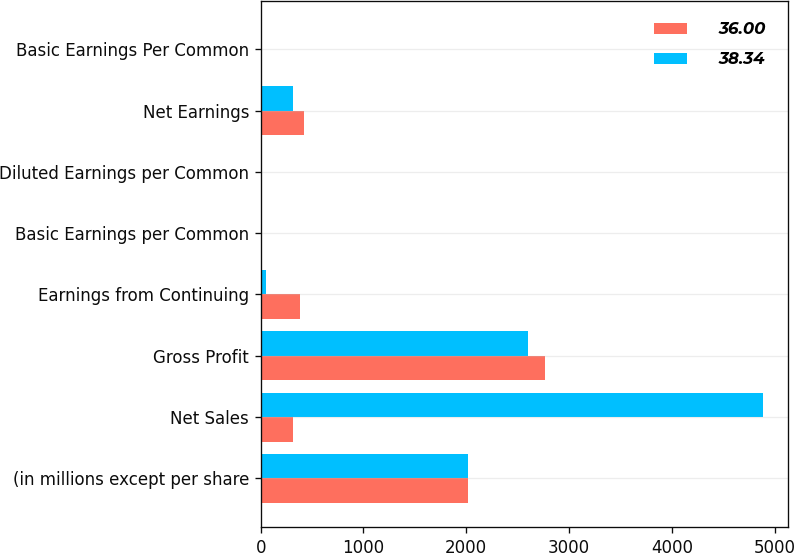<chart> <loc_0><loc_0><loc_500><loc_500><stacked_bar_chart><ecel><fcel>(in millions except per share<fcel>Net Sales<fcel>Gross Profit<fcel>Earnings from Continuing<fcel>Basic Earnings per Common<fcel>Diluted Earnings per Common<fcel>Net Earnings<fcel>Basic Earnings Per Common<nl><fcel>36<fcel>2017<fcel>316<fcel>2769<fcel>386<fcel>0.22<fcel>0.22<fcel>419<fcel>0.24<nl><fcel>38.34<fcel>2016<fcel>4885<fcel>2601<fcel>56<fcel>0.04<fcel>0.04<fcel>316<fcel>0.21<nl></chart> 